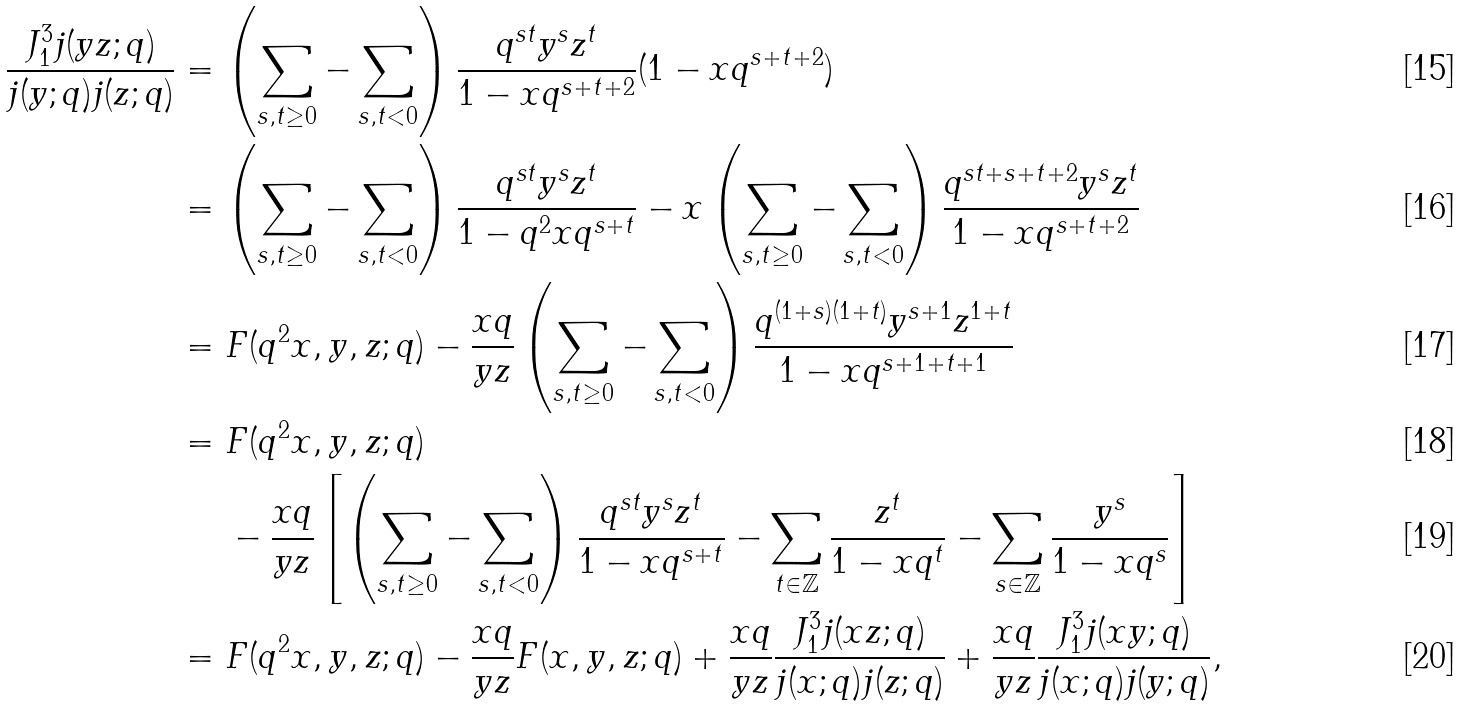Convert formula to latex. <formula><loc_0><loc_0><loc_500><loc_500>\frac { J _ { 1 } ^ { 3 } j ( y z ; q ) } { j ( y ; q ) j ( z ; q ) } & = \left ( \sum _ { s , t \geq 0 } - \sum _ { s , t < 0 } \right ) \frac { q ^ { s t } y ^ { s } z ^ { t } } { 1 - x q ^ { s + t + 2 } } ( 1 - x q ^ { s + t + 2 } ) \\ & = \left ( \sum _ { s , t \geq 0 } - \sum _ { s , t < 0 } \right ) \frac { q ^ { s t } y ^ { s } z ^ { t } } { 1 - q ^ { 2 } x q ^ { s + t } } - x \left ( \sum _ { s , t \geq 0 } - \sum _ { s , t < 0 } \right ) \frac { q ^ { s t + s + t + 2 } y ^ { s } z ^ { t } } { 1 - x q ^ { s + t + 2 } } \\ & = F ( q ^ { 2 } x , y , z ; q ) - \frac { x q } { y z } \left ( \sum _ { s , t \geq 0 } - \sum _ { s , t < 0 } \right ) \frac { q ^ { ( 1 + s ) ( 1 + t ) } y ^ { s + 1 } z ^ { 1 + t } } { 1 - x q ^ { s + 1 + t + 1 } } \\ & = F ( q ^ { 2 } x , y , z ; q ) \\ & \quad \ - \frac { x q } { y z } \left [ \left ( \sum _ { s , t \geq 0 } - \sum _ { s , t < 0 } \right ) \frac { q ^ { s t } y ^ { s } z ^ { t } } { 1 - x q ^ { s + t } } - \sum _ { t \in \mathbb { Z } } \frac { z ^ { t } } { 1 - x q ^ { t } } - \sum _ { s \in \mathbb { Z } } \frac { y ^ { s } } { 1 - x q ^ { s } } \right ] \\ & = F ( q ^ { 2 } x , y , z ; q ) - \frac { x q } { y z } F ( x , y , z ; q ) + \frac { x q } { y z } \frac { J _ { 1 } ^ { 3 } j ( x z ; q ) } { j ( x ; q ) j ( z ; q ) } + \frac { x q } { y z } \frac { J _ { 1 } ^ { 3 } j ( x y ; q ) } { j ( x ; q ) j ( y ; q ) } ,</formula> 